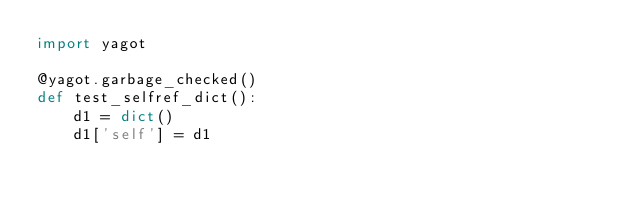<code> <loc_0><loc_0><loc_500><loc_500><_Python_>import yagot

@yagot.garbage_checked()
def test_selfref_dict():
    d1 = dict()
    d1['self'] = d1
</code> 